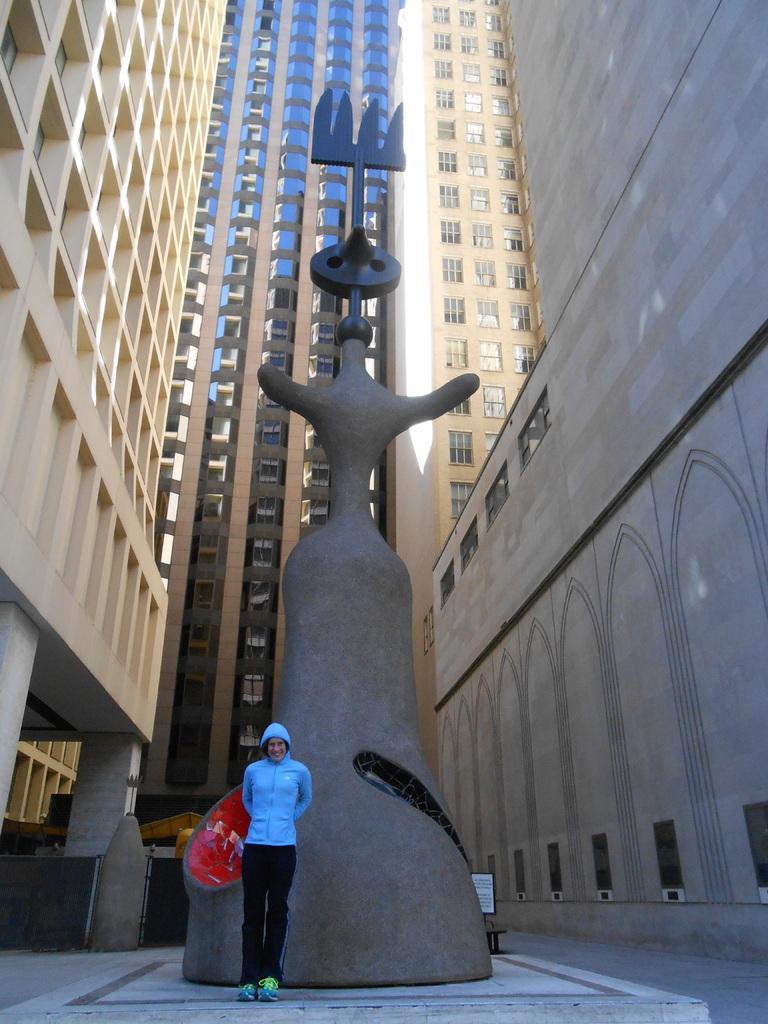Describe this image in one or two sentences. This is the picture of a place where we have a person standing in front of the statue and around there are some buildings. 